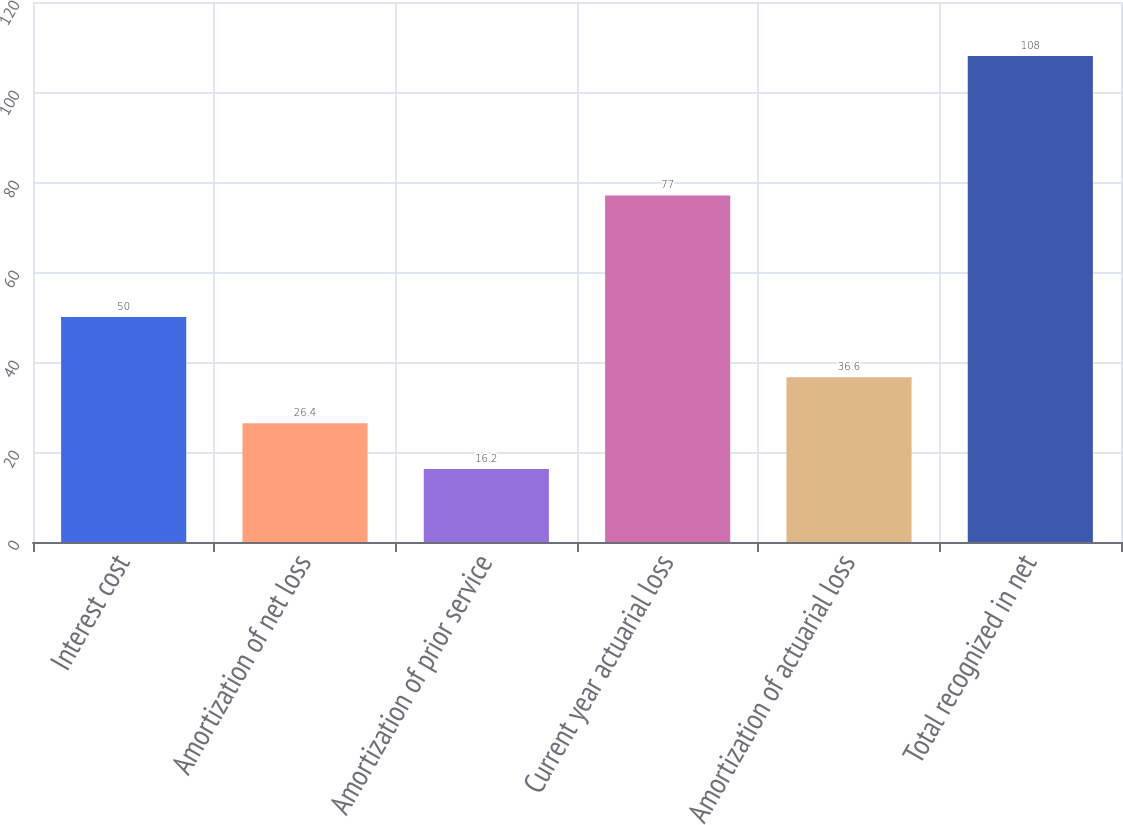Convert chart. <chart><loc_0><loc_0><loc_500><loc_500><bar_chart><fcel>Interest cost<fcel>Amortization of net loss<fcel>Amortization of prior service<fcel>Current year actuarial loss<fcel>Amortization of actuarial loss<fcel>Total recognized in net<nl><fcel>50<fcel>26.4<fcel>16.2<fcel>77<fcel>36.6<fcel>108<nl></chart> 